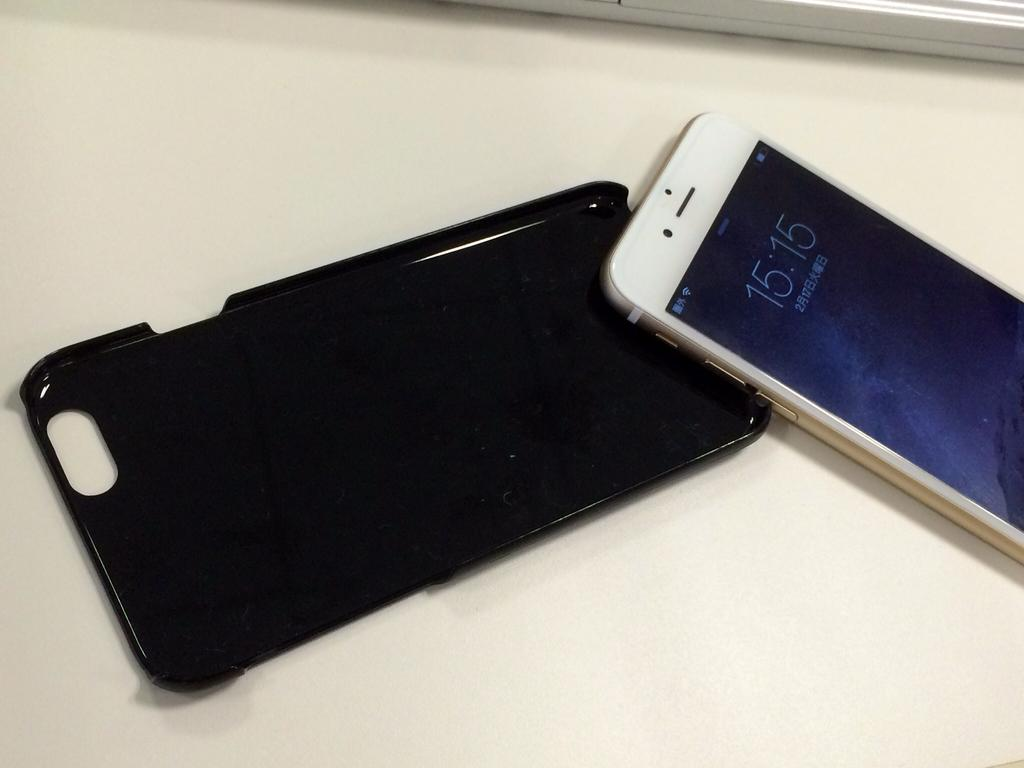Provide a one-sentence caption for the provided image. A white iPhone that is detached from its cover shows that the time is 15:15. 